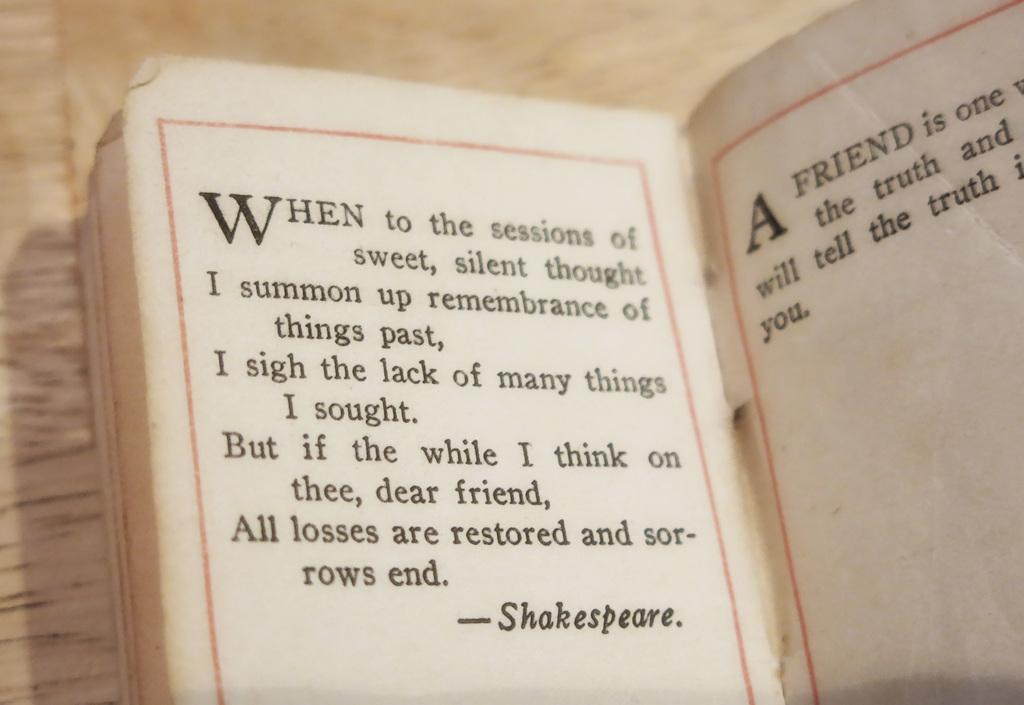<image>
Provide a brief description of the given image. A book is opened to lines written by Shakespeare. 